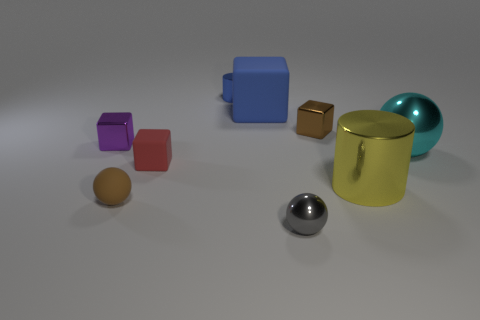Subtract all tiny brown blocks. How many blocks are left? 3 Subtract 1 spheres. How many spheres are left? 2 Subtract all cyan balls. How many balls are left? 2 Subtract all cylinders. How many objects are left? 7 Subtract all cyan cylinders. Subtract all purple spheres. How many cylinders are left? 2 Subtract all red blocks. How many cyan balls are left? 1 Subtract all blue matte things. Subtract all spheres. How many objects are left? 5 Add 8 purple shiny objects. How many purple shiny objects are left? 9 Add 5 big blue metal blocks. How many big blue metal blocks exist? 5 Subtract 0 blue spheres. How many objects are left? 9 